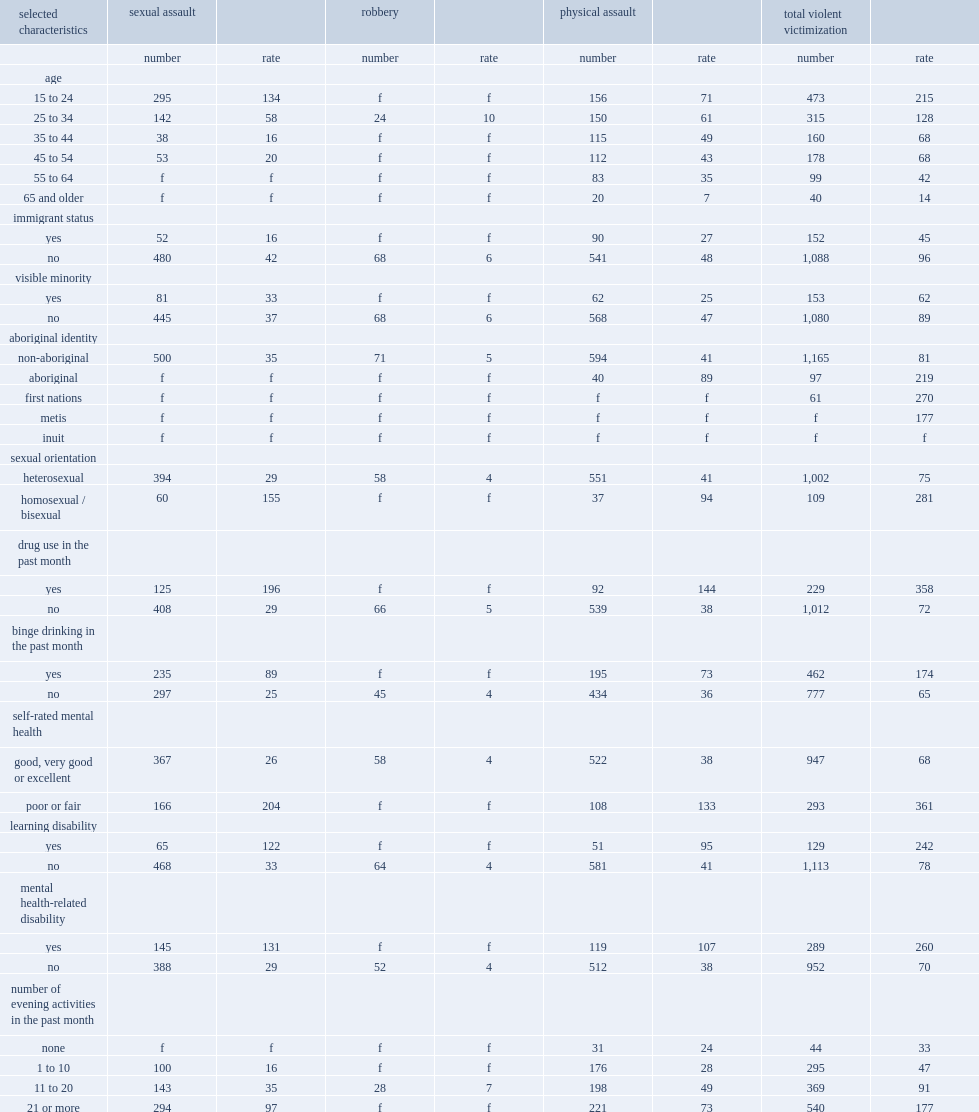How many times higher is the rate of aboriginal females who reported experiencing violent victimizations than that of non-aboriginal females? 2.703704. What is first nations females' incidence rate of overall violent victimization per 1,000 population? 270.0. What is metis females' rate of violent victimizations per 1,000 population? 177.0. Give me the full table as a dictionary. {'header': ['selected characteristics', 'sexual assault', '', 'robbery', '', 'physical assault', '', 'total violent victimization', ''], 'rows': [['', 'number', 'rate', 'number', 'rate', 'number', 'rate', 'number', 'rate'], ['age', '', '', '', '', '', '', '', ''], ['15 to 24', '295', '134', 'f', 'f', '156', '71', '473', '215'], ['25 to 34', '142', '58', '24', '10', '150', '61', '315', '128'], ['35 to 44', '38', '16', 'f', 'f', '115', '49', '160', '68'], ['45 to 54', '53', '20', 'f', 'f', '112', '43', '178', '68'], ['55 to 64', 'f', 'f', 'f', 'f', '83', '35', '99', '42'], ['65 and older', 'f', 'f', 'f', 'f', '20', '7', '40', '14'], ['immigrant status', '', '', '', '', '', '', '', ''], ['yes', '52', '16', 'f', 'f', '90', '27', '152', '45'], ['no', '480', '42', '68', '6', '541', '48', '1,088', '96'], ['visible minority', '', '', '', '', '', '', '', ''], ['yes', '81', '33', 'f', 'f', '62', '25', '153', '62'], ['no', '445', '37', '68', '6', '568', '47', '1,080', '89'], ['aboriginal identity', '', '', '', '', '', '', '', ''], ['non-aboriginal', '500', '35', '71', '5', '594', '41', '1,165', '81'], ['aboriginal', 'f', 'f', 'f', 'f', '40', '89', '97', '219'], ['first nations', 'f', 'f', 'f', 'f', 'f', 'f', '61', '270'], ['metis', 'f', 'f', 'f', 'f', 'f', 'f', 'f', '177'], ['inuit', 'f', 'f', 'f', 'f', 'f', 'f', 'f', 'f'], ['sexual orientation', '', '', '', '', '', '', '', ''], ['heterosexual', '394', '29', '58', '4', '551', '41', '1,002', '75'], ['homosexual / bisexual', '60', '155', 'f', 'f', '37', '94', '109', '281'], ['drug use in the past month', '', '', '', '', '', '', '', ''], ['yes', '125', '196', 'f', 'f', '92', '144', '229', '358'], ['no', '408', '29', '66', '5', '539', '38', '1,012', '72'], ['binge drinking in the past month', '', '', '', '', '', '', '', ''], ['yes', '235', '89', 'f', 'f', '195', '73', '462', '174'], ['no', '297', '25', '45', '4', '434', '36', '777', '65'], ['self-rated mental health', '', '', '', '', '', '', '', ''], ['good, very good or excellent', '367', '26', '58', '4', '522', '38', '947', '68'], ['poor or fair', '166', '204', 'f', 'f', '108', '133', '293', '361'], ['learning disability', '', '', '', '', '', '', '', ''], ['yes', '65', '122', 'f', 'f', '51', '95', '129', '242'], ['no', '468', '33', '64', '4', '581', '41', '1,113', '78'], ['mental health-related disability', '', '', '', '', '', '', '', ''], ['yes', '145', '131', 'f', 'f', '119', '107', '289', '260'], ['no', '388', '29', '52', '4', '512', '38', '952', '70'], ['number of evening activities in the past month', '', '', '', '', '', '', '', ''], ['none', 'f', 'f', 'f', 'f', '31', '24', '44', '33'], ['1 to 10', '100', '16', 'f', 'f', '176', '28', '295', '47'], ['11 to 20', '143', '35', '28', '7', '198', '49', '369', '91'], ['21 or more', '294', '97', 'f', 'f', '221', '73', '540', '177']]} 